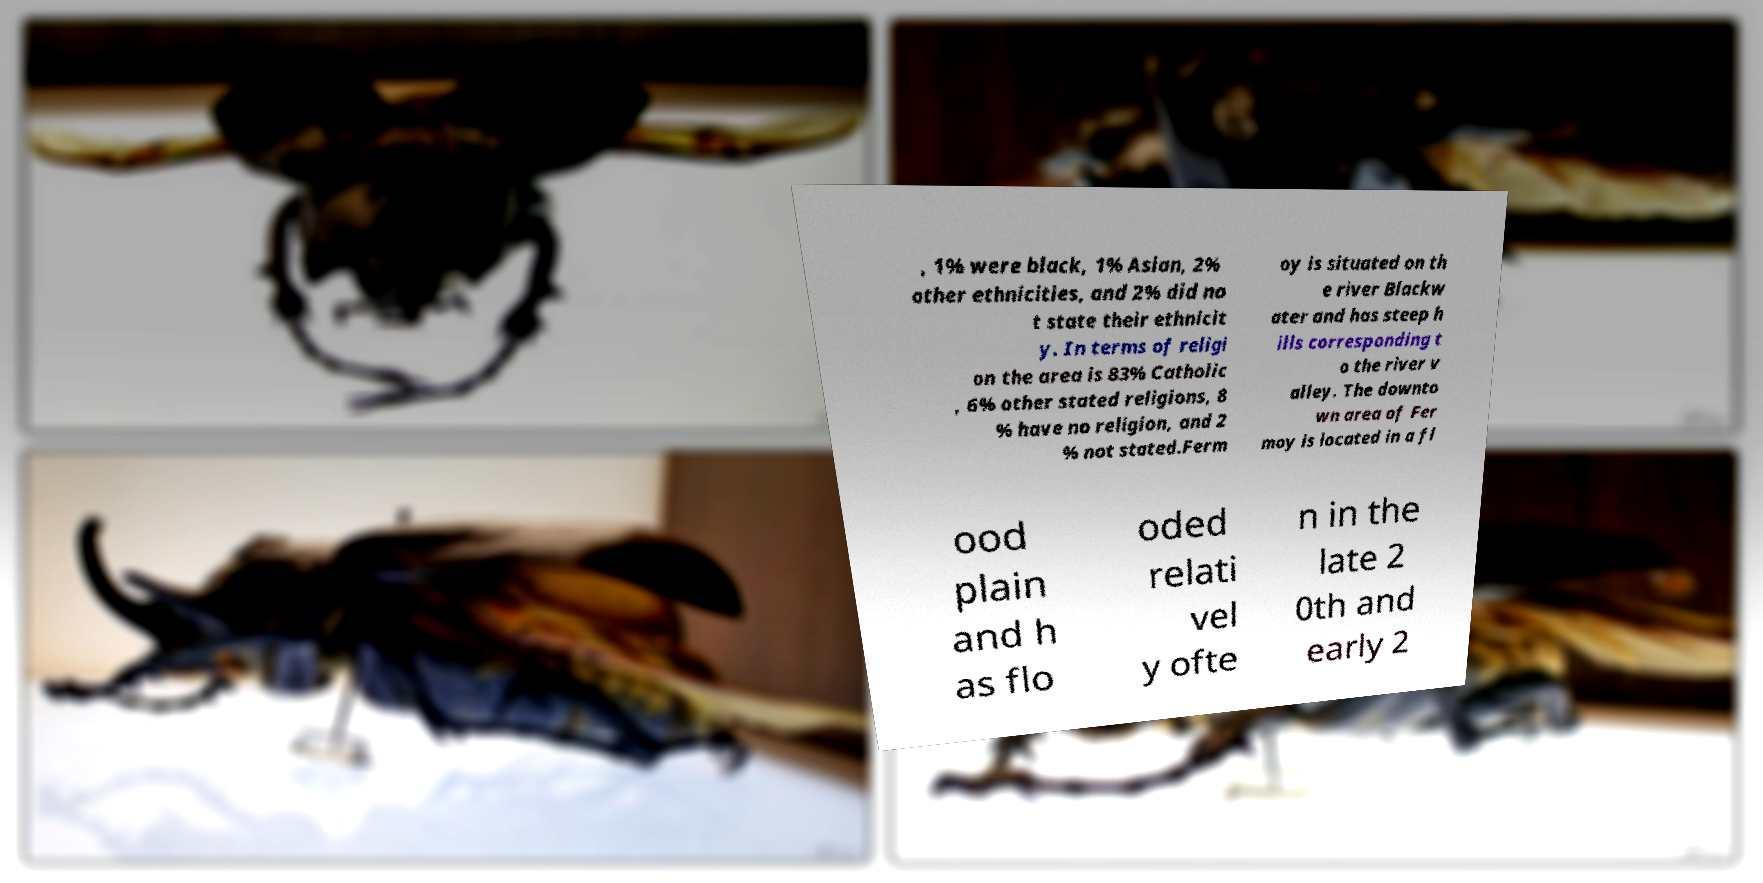There's text embedded in this image that I need extracted. Can you transcribe it verbatim? , 1% were black, 1% Asian, 2% other ethnicities, and 2% did no t state their ethnicit y. In terms of religi on the area is 83% Catholic , 6% other stated religions, 8 % have no religion, and 2 % not stated.Ferm oy is situated on th e river Blackw ater and has steep h ills corresponding t o the river v alley. The downto wn area of Fer moy is located in a fl ood plain and h as flo oded relati vel y ofte n in the late 2 0th and early 2 